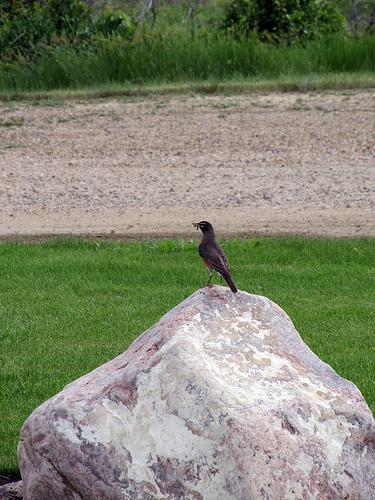Question: what is in the background?
Choices:
A. Fireplace.
B. City.
C. Dirt road.
D. Park.
Answer with the letter. Answer: C Question: where is the bird?
Choices:
A. In a tree.
B. On a rock.
C. In the water.
D. In the air.
Answer with the letter. Answer: B 